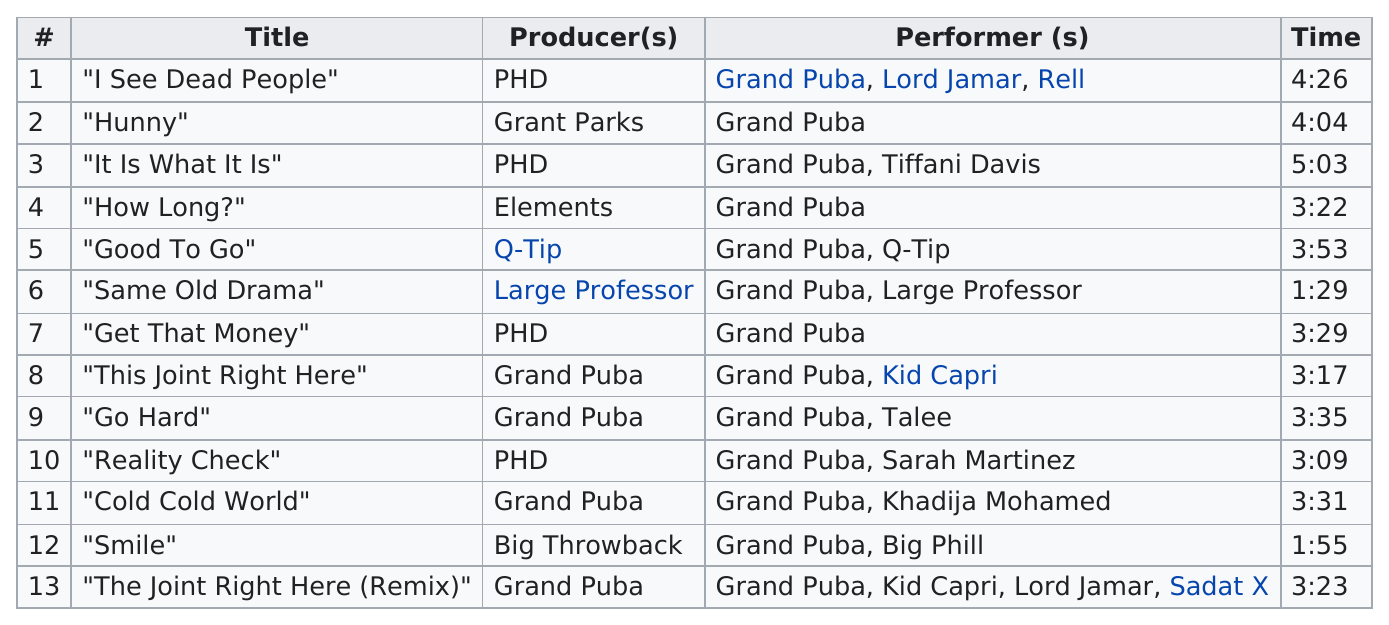Specify some key components in this picture. Out of the total number of tracks, the number of tracks with at least two performers is 10. Large Professor is the first producer with the least amount of time. The song "Same Old Drama" is the shortest song. The total number of titles is 13. The title "Same Old Drama" has the least amount of time. 